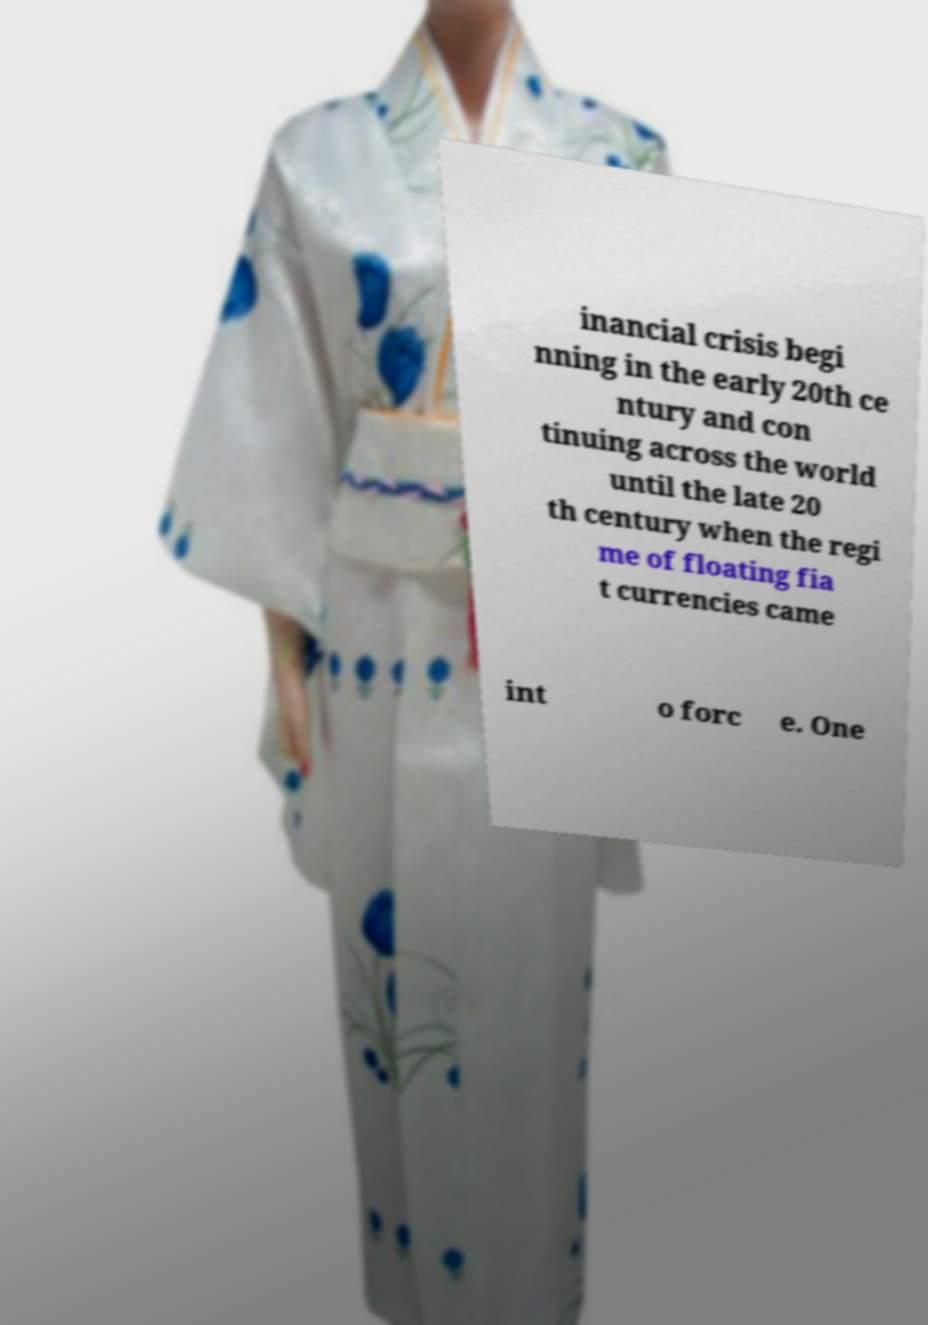There's text embedded in this image that I need extracted. Can you transcribe it verbatim? inancial crisis begi nning in the early 20th ce ntury and con tinuing across the world until the late 20 th century when the regi me of floating fia t currencies came int o forc e. One 